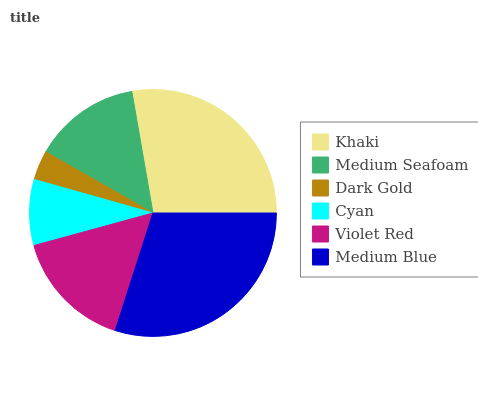Is Dark Gold the minimum?
Answer yes or no. Yes. Is Medium Blue the maximum?
Answer yes or no. Yes. Is Medium Seafoam the minimum?
Answer yes or no. No. Is Medium Seafoam the maximum?
Answer yes or no. No. Is Khaki greater than Medium Seafoam?
Answer yes or no. Yes. Is Medium Seafoam less than Khaki?
Answer yes or no. Yes. Is Medium Seafoam greater than Khaki?
Answer yes or no. No. Is Khaki less than Medium Seafoam?
Answer yes or no. No. Is Violet Red the high median?
Answer yes or no. Yes. Is Medium Seafoam the low median?
Answer yes or no. Yes. Is Dark Gold the high median?
Answer yes or no. No. Is Dark Gold the low median?
Answer yes or no. No. 